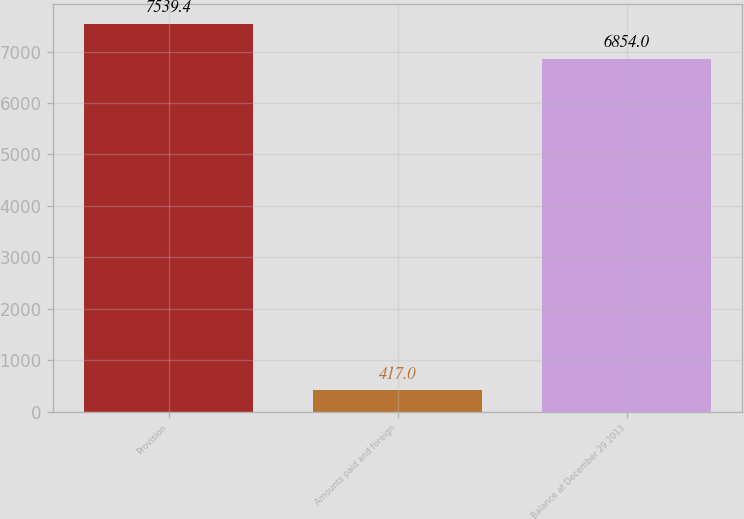<chart> <loc_0><loc_0><loc_500><loc_500><bar_chart><fcel>Provision<fcel>Amounts paid and foreign<fcel>Balance at December 29 2013<nl><fcel>7539.4<fcel>417<fcel>6854<nl></chart> 